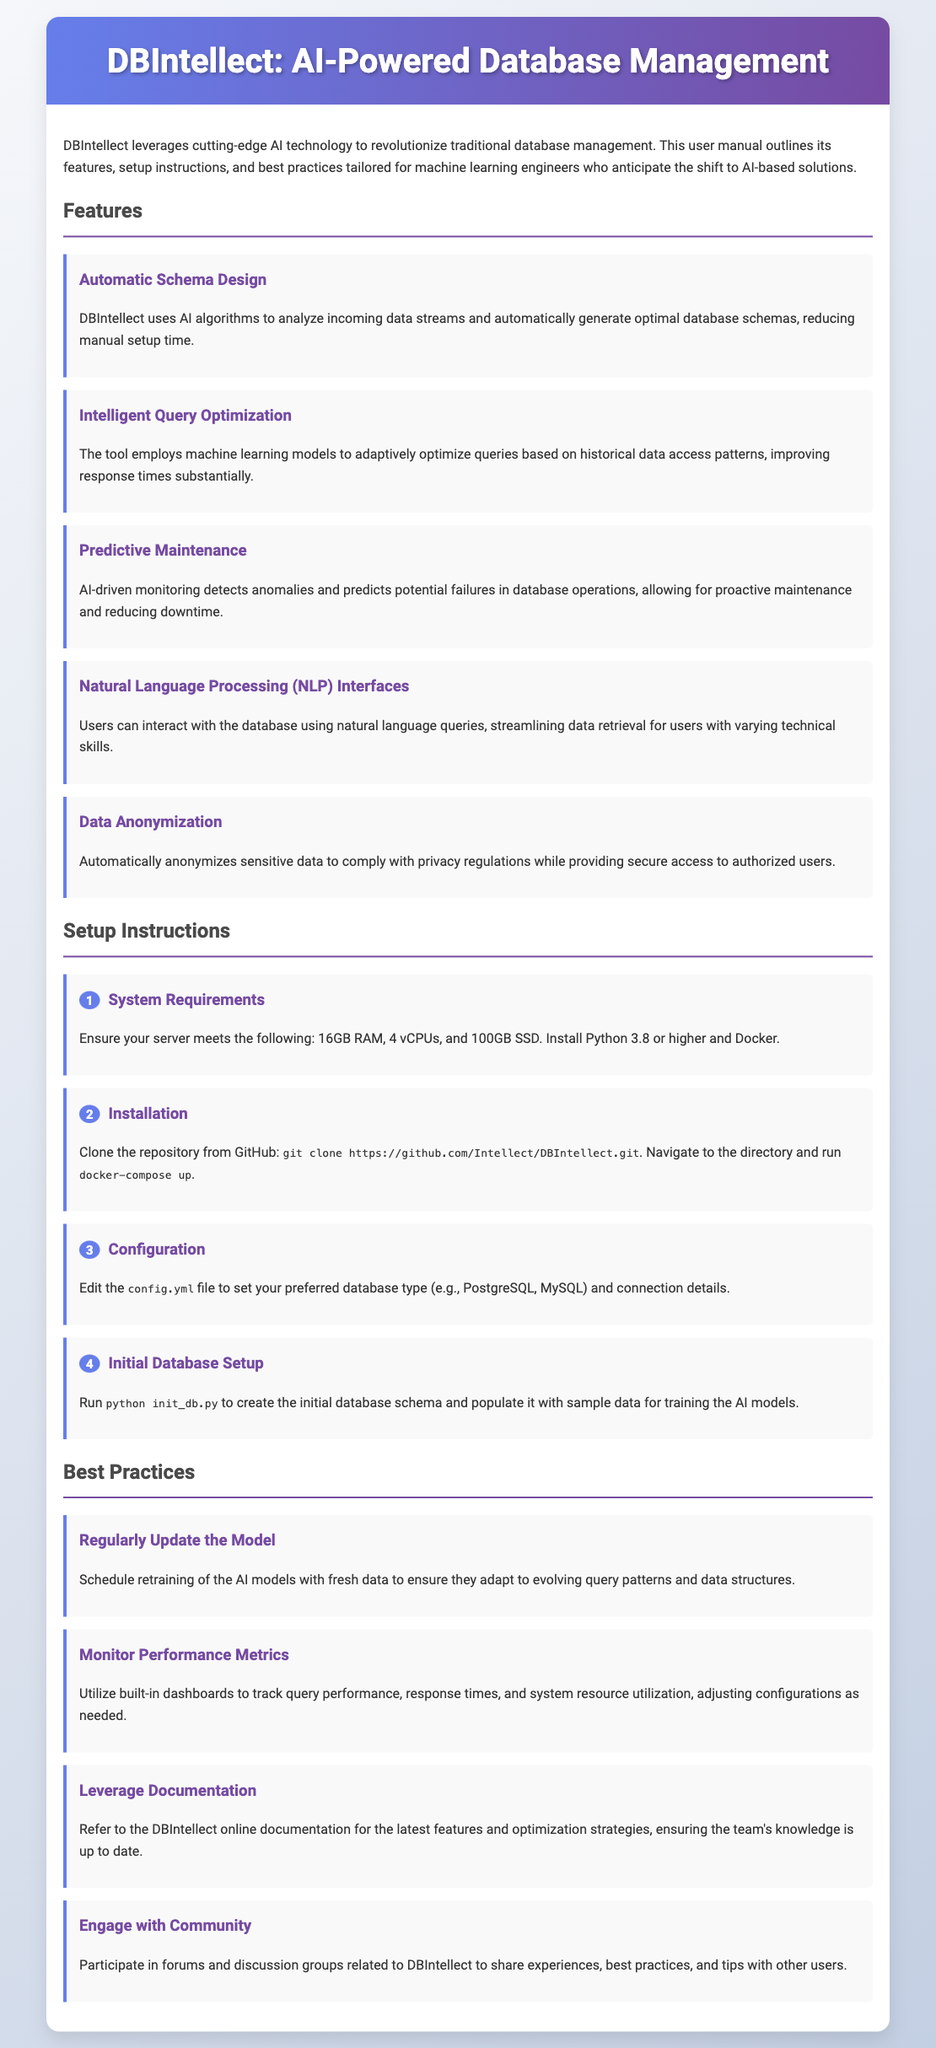What is the title of the tool? The title of the tool is presented in the header of the document.
Answer: DBIntellect: AI-Powered Database Management How many features are listed in the document? The document mentions multiple features in the Features section.
Answer: Five What is required for the system? The document lists requirements in the Setup Instructions section.
Answer: 16GB RAM, 4 vCPUs, and 100GB SSD What should you run after installation to create the initial database? This action is mentioned as a step in the Setup Instructions.
Answer: python init_db.py What is one of the best practices mentioned? The Best Practices section lists several recommendations for users.
Answer: Regularly Update the Model What technology is used for intelligent query optimization? The document specifies the technology utilized in the Features section.
Answer: Machine learning models What step comes after editing the config file? This question refers to the order of steps in the Setup Instructions.
Answer: Initial Database Setup What type of interface does DBIntellect provide for users? This is described under Features in the document.
Answer: Natural Language Processing (NLP) Interfaces 